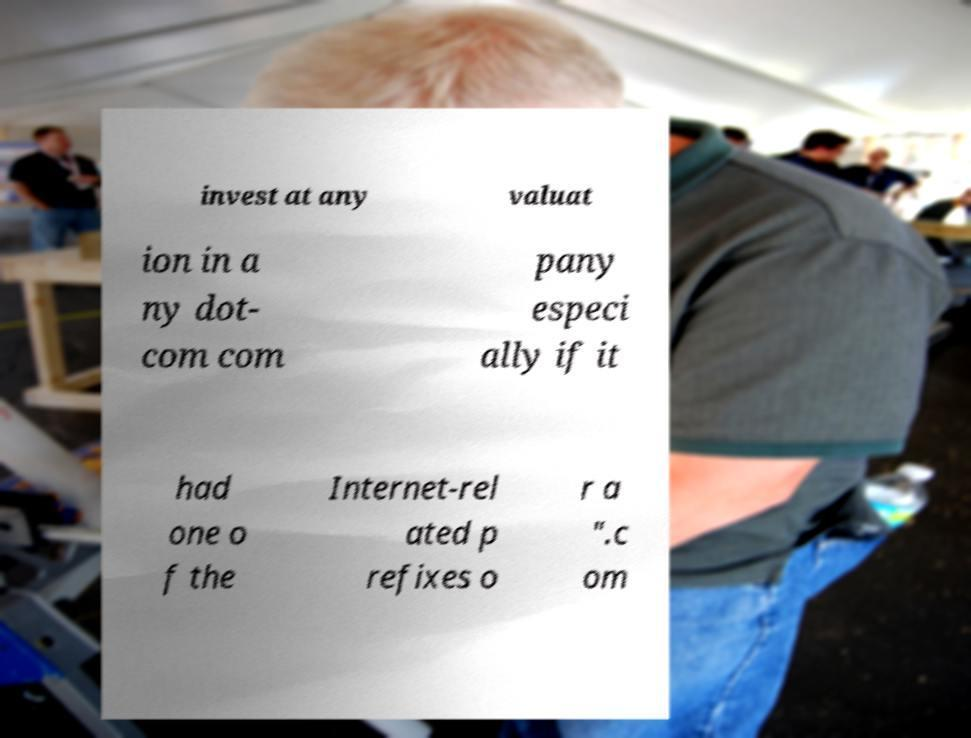Please read and relay the text visible in this image. What does it say? invest at any valuat ion in a ny dot- com com pany especi ally if it had one o f the Internet-rel ated p refixes o r a ".c om 